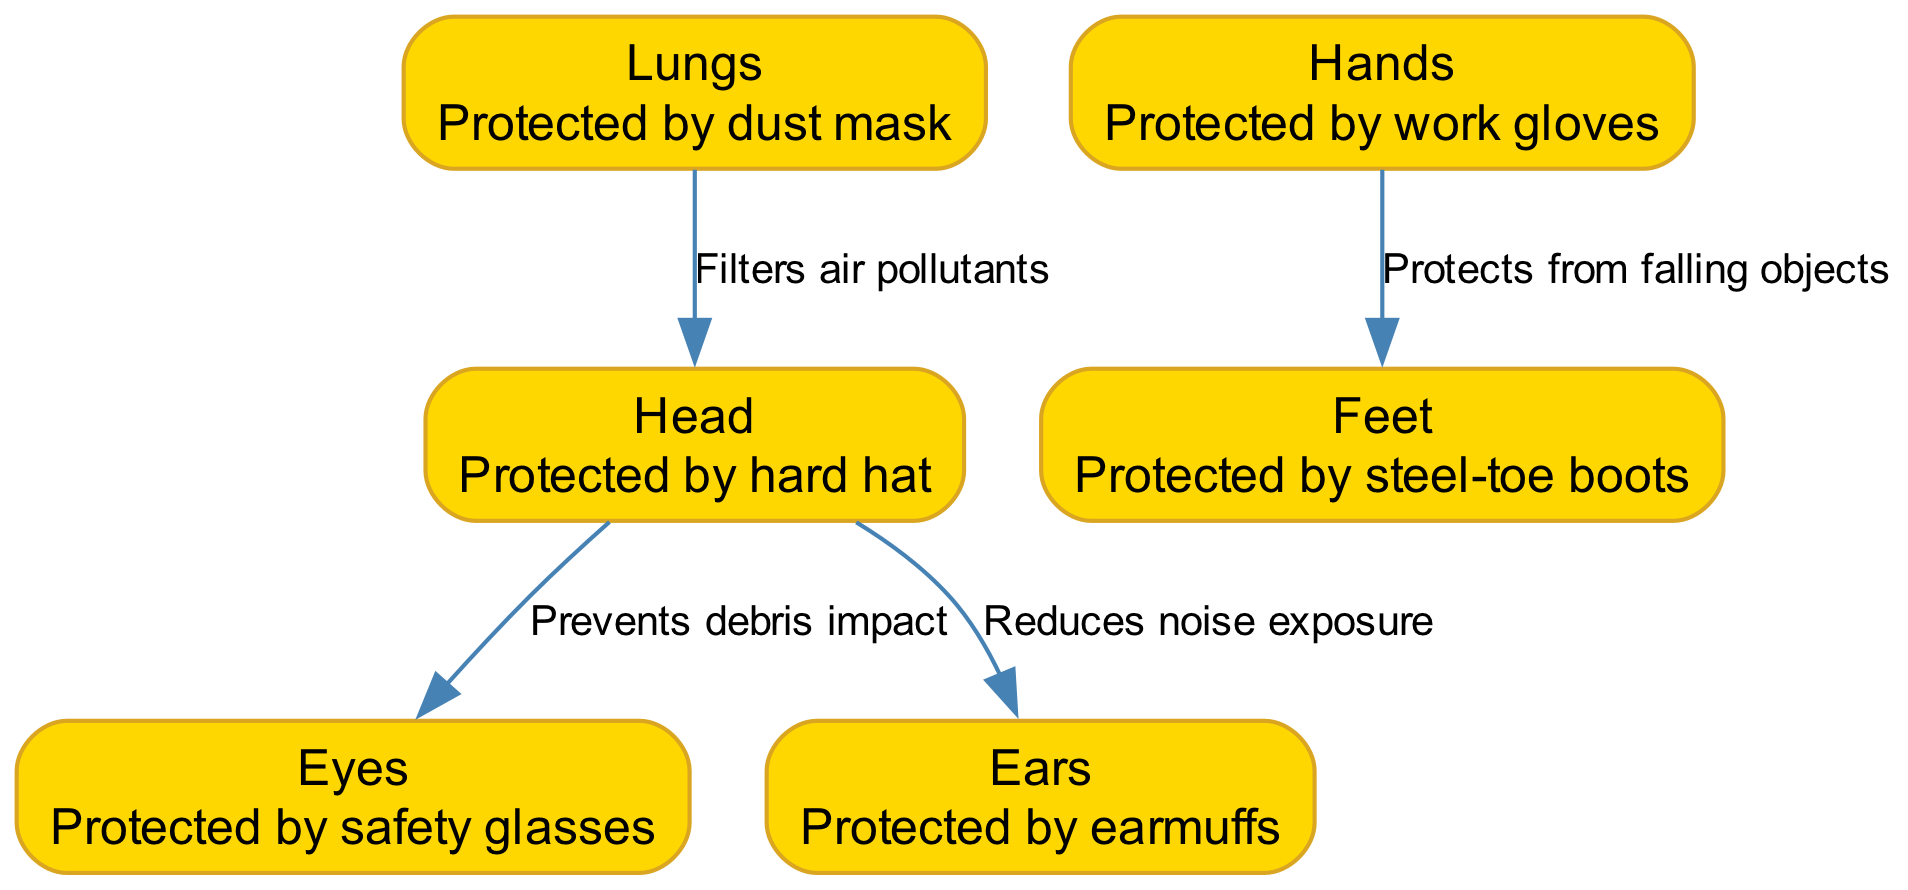What part of the body is protected by a hard hat? The diagram clearly labels the "Head" as being protected by the hard hat, which is the specific element indicated in the node description.
Answer: Head What piece of equipment protects the lungs? The diagram indicates that the "lungs" are protected by a "dust mask," as shown in the node description.
Answer: Dust mask How many nodes are there in the diagram? By counting the individual nodes listed, there are a total of six nodes: head, eyes, ears, lungs, hands, and feet.
Answer: 6 What do safety glasses protect? The diagram specifies that safety glasses protect the "Eyes," detailed in the corresponding node description.
Answer: Eyes What does the edge labeled "Prevents debris impact" connect? The edge labeled "Prevents debris impact" is drawn from the "Head" node to the "Eyes" node, showing the direct connection and preventive relationship between these two elements.
Answer: Head to Eyes Which protective equipment reduces noise exposure? The diagram shows that "ears" are protected by earmuffs, fulfilling the role of noise reduction as specified in the node description.
Answer: Earmuffs What is the relationship between hands and feet in the diagram? The edge connecting the "Hands" to "Feet" indicates that protection from falling objects is the relationship, showing the interdependence of safety for these body parts.
Answer: Protects from falling objects What colors are used for the nodes in the diagram? The nodes in the diagram are filled with the color #FFD700, which is a shade of gold, and outlined with the color #DAA520, a darker shade of gold.
Answer: Gold and dark gold Which equipment filters air pollutants according to the diagram? The diagram indicates that the "lungs" are protected by a "dust mask," serving the function of filtering air pollutants as described in the node.
Answer: Dust mask 